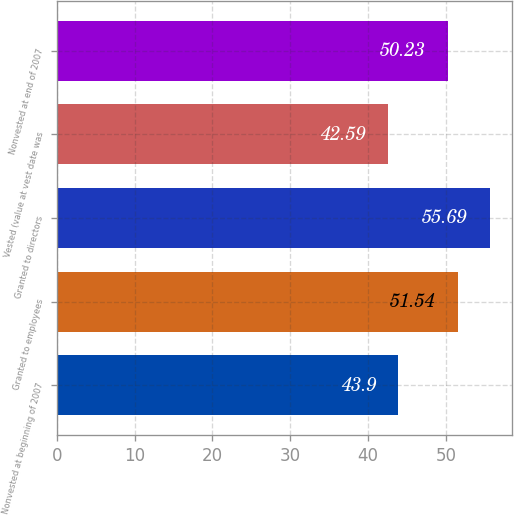<chart> <loc_0><loc_0><loc_500><loc_500><bar_chart><fcel>Nonvested at beginning of 2007<fcel>Granted to employees<fcel>Granted to directors<fcel>Vested (value at vest date was<fcel>Nonvested at end of 2007<nl><fcel>43.9<fcel>51.54<fcel>55.69<fcel>42.59<fcel>50.23<nl></chart> 